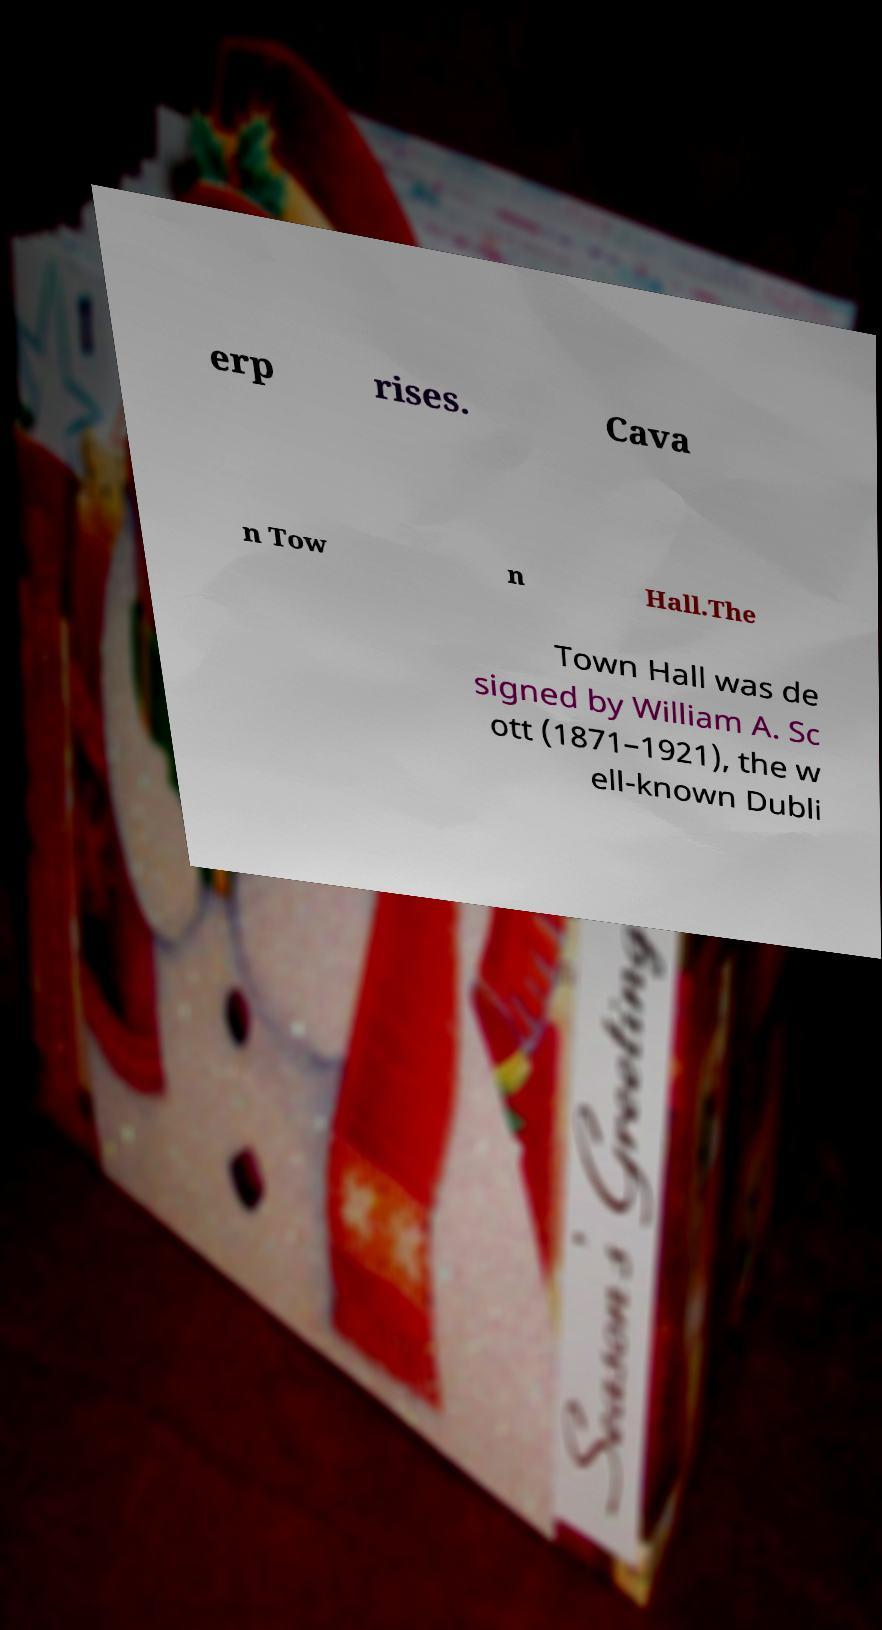There's text embedded in this image that I need extracted. Can you transcribe it verbatim? erp rises. Cava n Tow n Hall.The Town Hall was de signed by William A. Sc ott (1871–1921), the w ell-known Dubli 